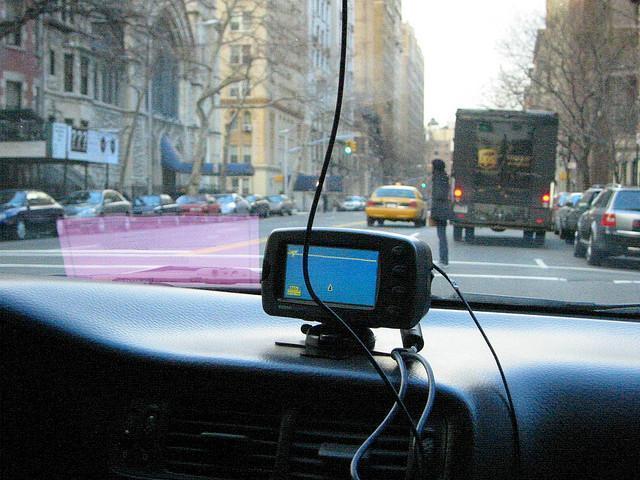How many cars are there?
Give a very brief answer. 5. 